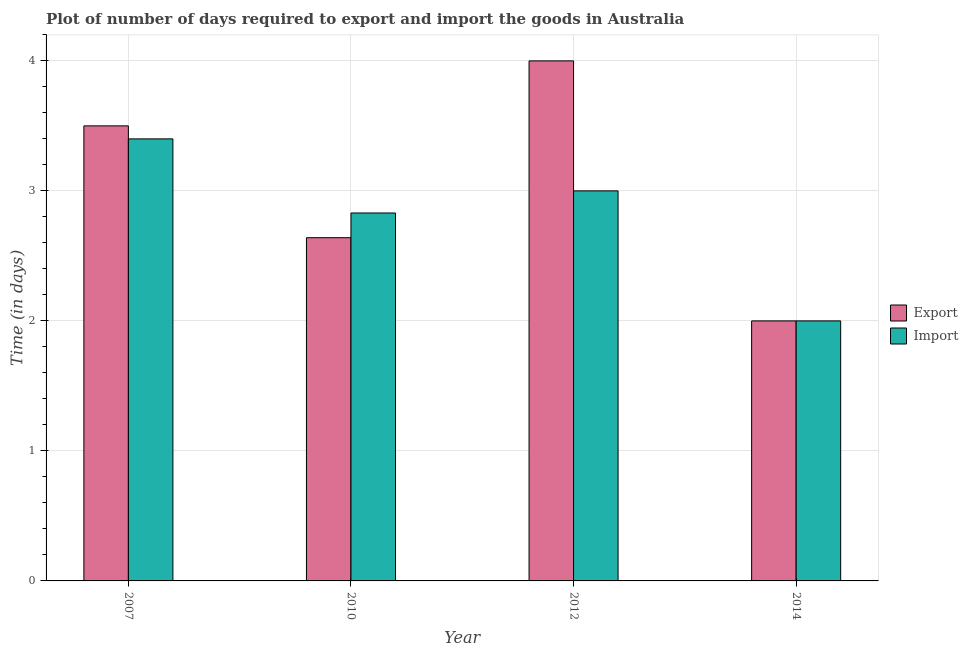How many groups of bars are there?
Provide a short and direct response. 4. Are the number of bars per tick equal to the number of legend labels?
Ensure brevity in your answer.  Yes. Are the number of bars on each tick of the X-axis equal?
Offer a very short reply. Yes. How many bars are there on the 1st tick from the left?
Your answer should be very brief. 2. What is the label of the 2nd group of bars from the left?
Offer a terse response. 2010. What is the time required to export in 2007?
Your answer should be very brief. 3.5. What is the total time required to import in the graph?
Ensure brevity in your answer.  11.23. What is the difference between the time required to export in 2007 and that in 2010?
Offer a terse response. 0.86. What is the difference between the time required to import in 2014 and the time required to export in 2010?
Offer a very short reply. -0.83. What is the average time required to import per year?
Ensure brevity in your answer.  2.81. In the year 2014, what is the difference between the time required to import and time required to export?
Make the answer very short. 0. What is the ratio of the time required to import in 2010 to that in 2012?
Offer a very short reply. 0.94. Is the difference between the time required to export in 2007 and 2010 greater than the difference between the time required to import in 2007 and 2010?
Offer a terse response. No. What is the difference between the highest and the second highest time required to import?
Provide a short and direct response. 0.4. What is the difference between the highest and the lowest time required to export?
Give a very brief answer. 2. What does the 2nd bar from the left in 2007 represents?
Give a very brief answer. Import. What does the 1st bar from the right in 2014 represents?
Keep it short and to the point. Import. How many bars are there?
Your answer should be compact. 8. Are all the bars in the graph horizontal?
Offer a very short reply. No. What is the difference between two consecutive major ticks on the Y-axis?
Offer a terse response. 1. Are the values on the major ticks of Y-axis written in scientific E-notation?
Ensure brevity in your answer.  No. Does the graph contain grids?
Offer a terse response. Yes. Where does the legend appear in the graph?
Your answer should be very brief. Center right. How many legend labels are there?
Offer a terse response. 2. What is the title of the graph?
Provide a succinct answer. Plot of number of days required to export and import the goods in Australia. Does "Pregnant women" appear as one of the legend labels in the graph?
Your response must be concise. No. What is the label or title of the X-axis?
Keep it short and to the point. Year. What is the label or title of the Y-axis?
Make the answer very short. Time (in days). What is the Time (in days) of Import in 2007?
Provide a short and direct response. 3.4. What is the Time (in days) in Export in 2010?
Ensure brevity in your answer.  2.64. What is the Time (in days) of Import in 2010?
Ensure brevity in your answer.  2.83. What is the Time (in days) in Import in 2012?
Ensure brevity in your answer.  3. What is the Time (in days) in Export in 2014?
Your answer should be very brief. 2. What is the Time (in days) in Import in 2014?
Provide a short and direct response. 2. Across all years, what is the maximum Time (in days) of Export?
Make the answer very short. 4. Across all years, what is the minimum Time (in days) in Import?
Your answer should be very brief. 2. What is the total Time (in days) of Export in the graph?
Make the answer very short. 12.14. What is the total Time (in days) in Import in the graph?
Your response must be concise. 11.23. What is the difference between the Time (in days) of Export in 2007 and that in 2010?
Your answer should be compact. 0.86. What is the difference between the Time (in days) in Import in 2007 and that in 2010?
Make the answer very short. 0.57. What is the difference between the Time (in days) of Export in 2007 and that in 2014?
Offer a very short reply. 1.5. What is the difference between the Time (in days) of Export in 2010 and that in 2012?
Provide a short and direct response. -1.36. What is the difference between the Time (in days) of Import in 2010 and that in 2012?
Provide a succinct answer. -0.17. What is the difference between the Time (in days) of Export in 2010 and that in 2014?
Your response must be concise. 0.64. What is the difference between the Time (in days) in Import in 2010 and that in 2014?
Ensure brevity in your answer.  0.83. What is the difference between the Time (in days) of Export in 2007 and the Time (in days) of Import in 2010?
Offer a terse response. 0.67. What is the difference between the Time (in days) in Export in 2010 and the Time (in days) in Import in 2012?
Your answer should be compact. -0.36. What is the difference between the Time (in days) in Export in 2010 and the Time (in days) in Import in 2014?
Offer a terse response. 0.64. What is the average Time (in days) in Export per year?
Keep it short and to the point. 3.04. What is the average Time (in days) in Import per year?
Provide a succinct answer. 2.81. In the year 2010, what is the difference between the Time (in days) in Export and Time (in days) in Import?
Provide a succinct answer. -0.19. In the year 2012, what is the difference between the Time (in days) in Export and Time (in days) in Import?
Make the answer very short. 1. What is the ratio of the Time (in days) in Export in 2007 to that in 2010?
Offer a terse response. 1.33. What is the ratio of the Time (in days) of Import in 2007 to that in 2010?
Your response must be concise. 1.2. What is the ratio of the Time (in days) in Import in 2007 to that in 2012?
Provide a succinct answer. 1.13. What is the ratio of the Time (in days) of Export in 2007 to that in 2014?
Your answer should be very brief. 1.75. What is the ratio of the Time (in days) of Import in 2007 to that in 2014?
Offer a very short reply. 1.7. What is the ratio of the Time (in days) in Export in 2010 to that in 2012?
Give a very brief answer. 0.66. What is the ratio of the Time (in days) in Import in 2010 to that in 2012?
Offer a terse response. 0.94. What is the ratio of the Time (in days) in Export in 2010 to that in 2014?
Your answer should be compact. 1.32. What is the ratio of the Time (in days) of Import in 2010 to that in 2014?
Make the answer very short. 1.42. What is the ratio of the Time (in days) of Import in 2012 to that in 2014?
Keep it short and to the point. 1.5. What is the difference between the highest and the second highest Time (in days) in Export?
Offer a very short reply. 0.5. What is the difference between the highest and the lowest Time (in days) in Export?
Your answer should be very brief. 2. 